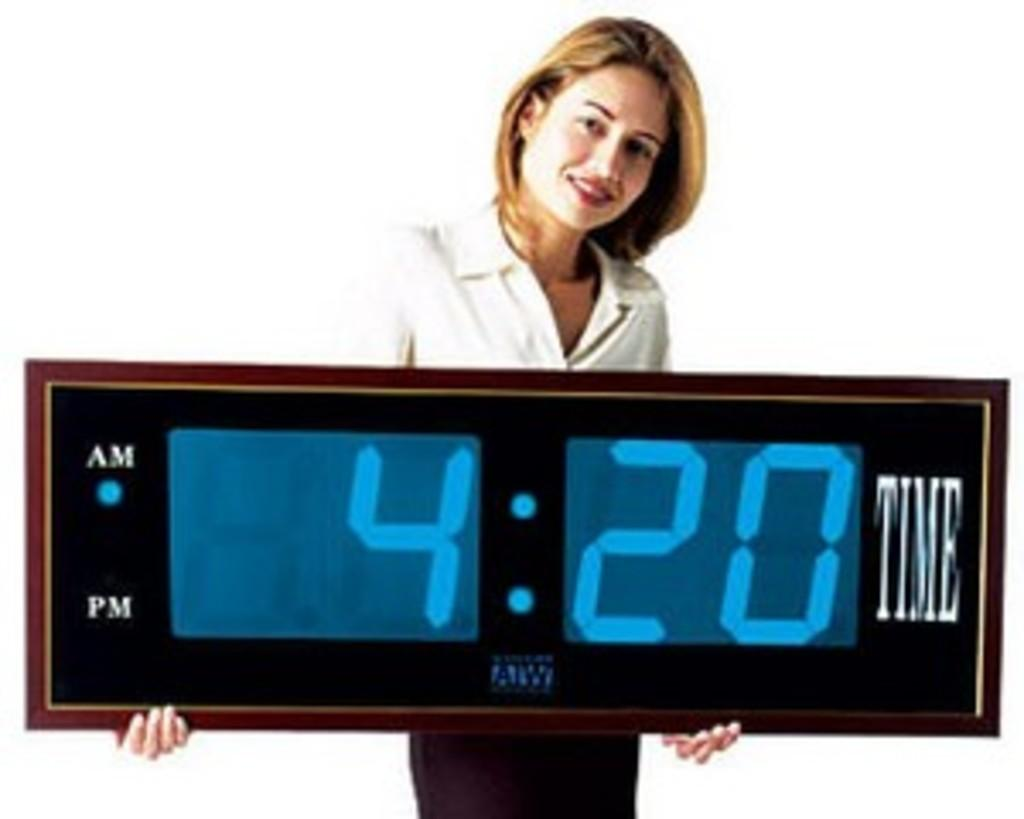<image>
Summarize the visual content of the image. the time 4:20 is on an alarm clock 